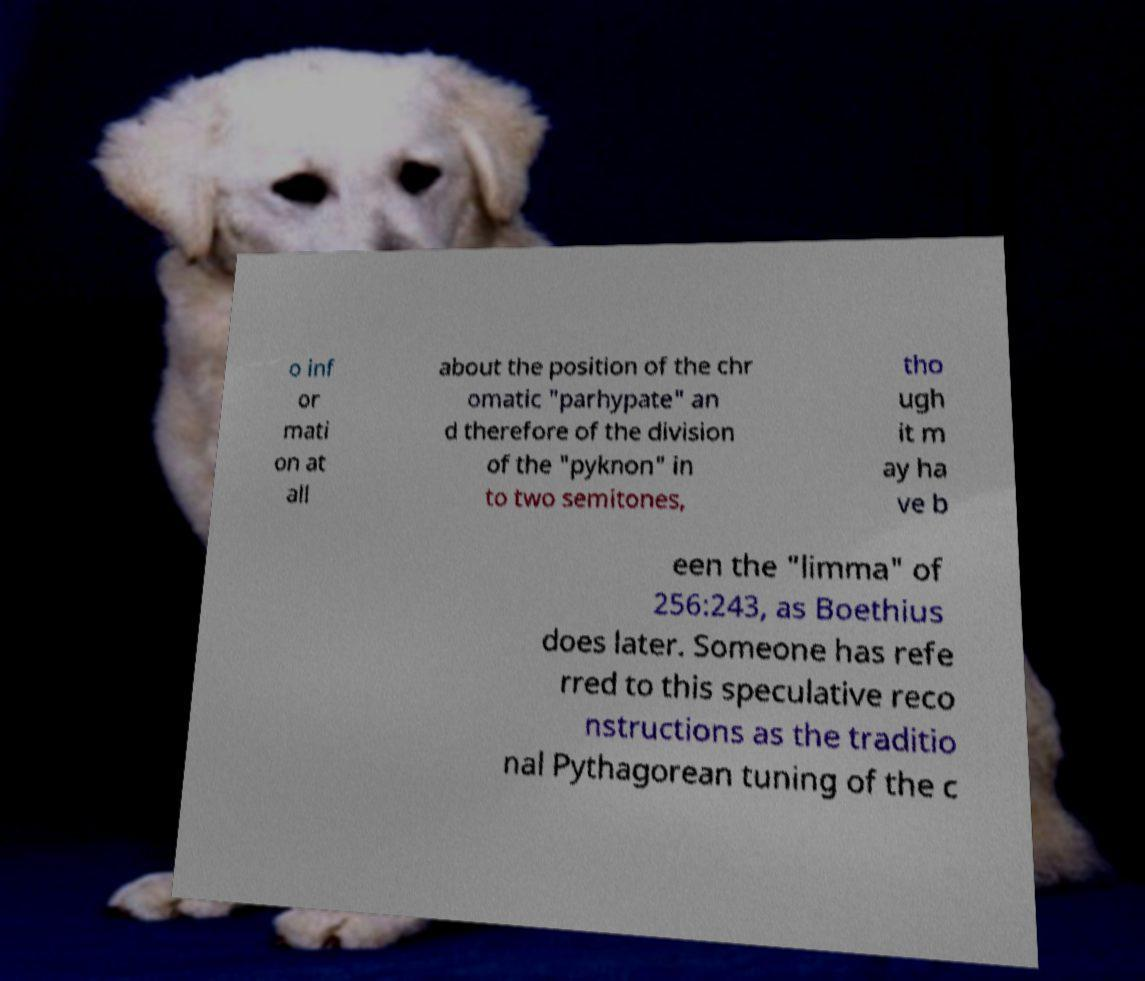There's text embedded in this image that I need extracted. Can you transcribe it verbatim? o inf or mati on at all about the position of the chr omatic "parhypate" an d therefore of the division of the "pyknon" in to two semitones, tho ugh it m ay ha ve b een the "limma" of 256:243, as Boethius does later. Someone has refe rred to this speculative reco nstructions as the traditio nal Pythagorean tuning of the c 